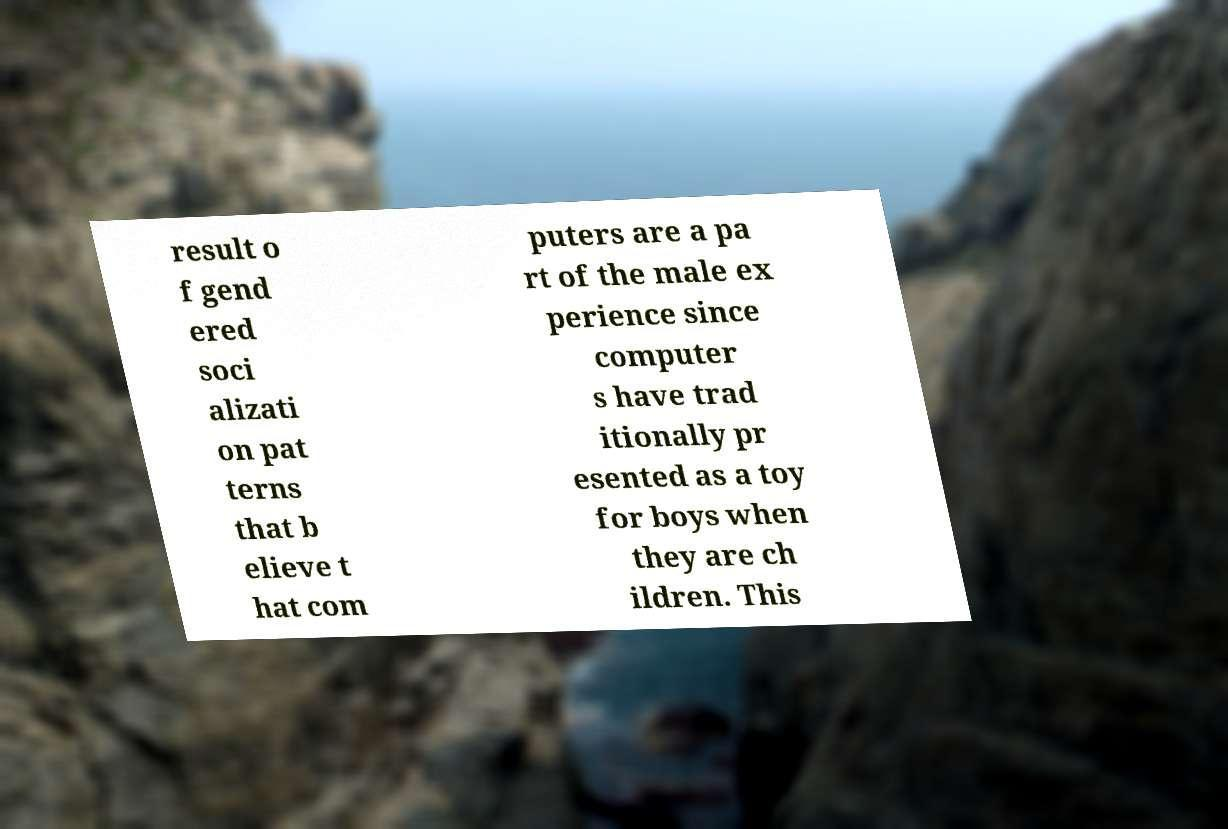Could you assist in decoding the text presented in this image and type it out clearly? result o f gend ered soci alizati on pat terns that b elieve t hat com puters are a pa rt of the male ex perience since computer s have trad itionally pr esented as a toy for boys when they are ch ildren. This 